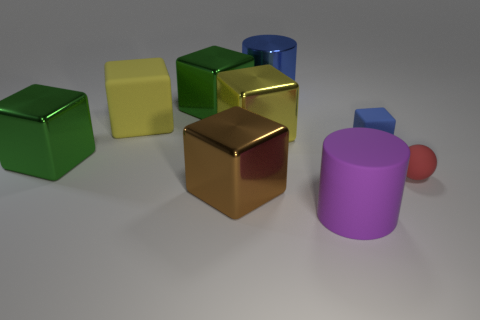Subtract all rubber cubes. How many cubes are left? 4 Subtract all brown cubes. How many cubes are left? 5 Subtract all gray blocks. Subtract all brown cylinders. How many blocks are left? 6 Add 1 large purple shiny cylinders. How many objects exist? 10 Subtract all cylinders. How many objects are left? 7 Add 3 tiny green metallic things. How many tiny green metallic things exist? 3 Subtract 0 red cylinders. How many objects are left? 9 Subtract all blue cylinders. Subtract all big green objects. How many objects are left? 6 Add 4 blue things. How many blue things are left? 6 